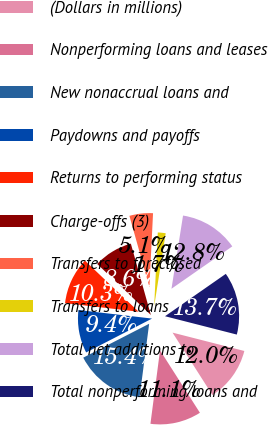Convert chart to OTSL. <chart><loc_0><loc_0><loc_500><loc_500><pie_chart><fcel>(Dollars in millions)<fcel>Nonperforming loans and leases<fcel>New nonaccrual loans and<fcel>Paydowns and payoffs<fcel>Returns to performing status<fcel>Charge-offs (3)<fcel>Transfers to foreclosed<fcel>Transfers to loans<fcel>Total net additions to<fcel>Total nonperforming loans and<nl><fcel>11.97%<fcel>11.11%<fcel>15.38%<fcel>9.4%<fcel>10.26%<fcel>8.55%<fcel>5.13%<fcel>1.71%<fcel>12.82%<fcel>13.67%<nl></chart> 